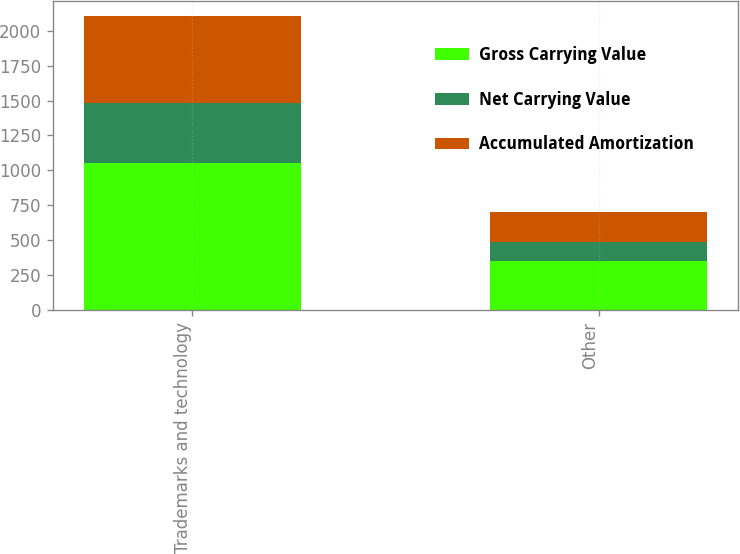Convert chart. <chart><loc_0><loc_0><loc_500><loc_500><stacked_bar_chart><ecel><fcel>Trademarks and technology<fcel>Other<nl><fcel>Gross Carrying Value<fcel>1054<fcel>351<nl><fcel>Net Carrying Value<fcel>432<fcel>134<nl><fcel>Accumulated Amortization<fcel>622<fcel>217<nl></chart> 